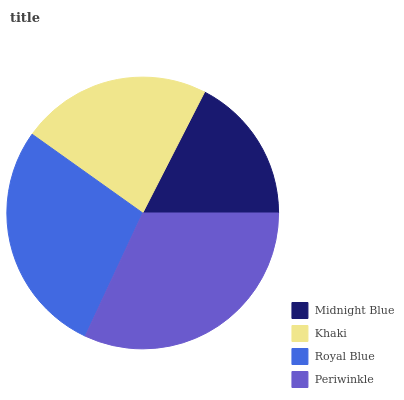Is Midnight Blue the minimum?
Answer yes or no. Yes. Is Periwinkle the maximum?
Answer yes or no. Yes. Is Khaki the minimum?
Answer yes or no. No. Is Khaki the maximum?
Answer yes or no. No. Is Khaki greater than Midnight Blue?
Answer yes or no. Yes. Is Midnight Blue less than Khaki?
Answer yes or no. Yes. Is Midnight Blue greater than Khaki?
Answer yes or no. No. Is Khaki less than Midnight Blue?
Answer yes or no. No. Is Royal Blue the high median?
Answer yes or no. Yes. Is Khaki the low median?
Answer yes or no. Yes. Is Periwinkle the high median?
Answer yes or no. No. Is Midnight Blue the low median?
Answer yes or no. No. 